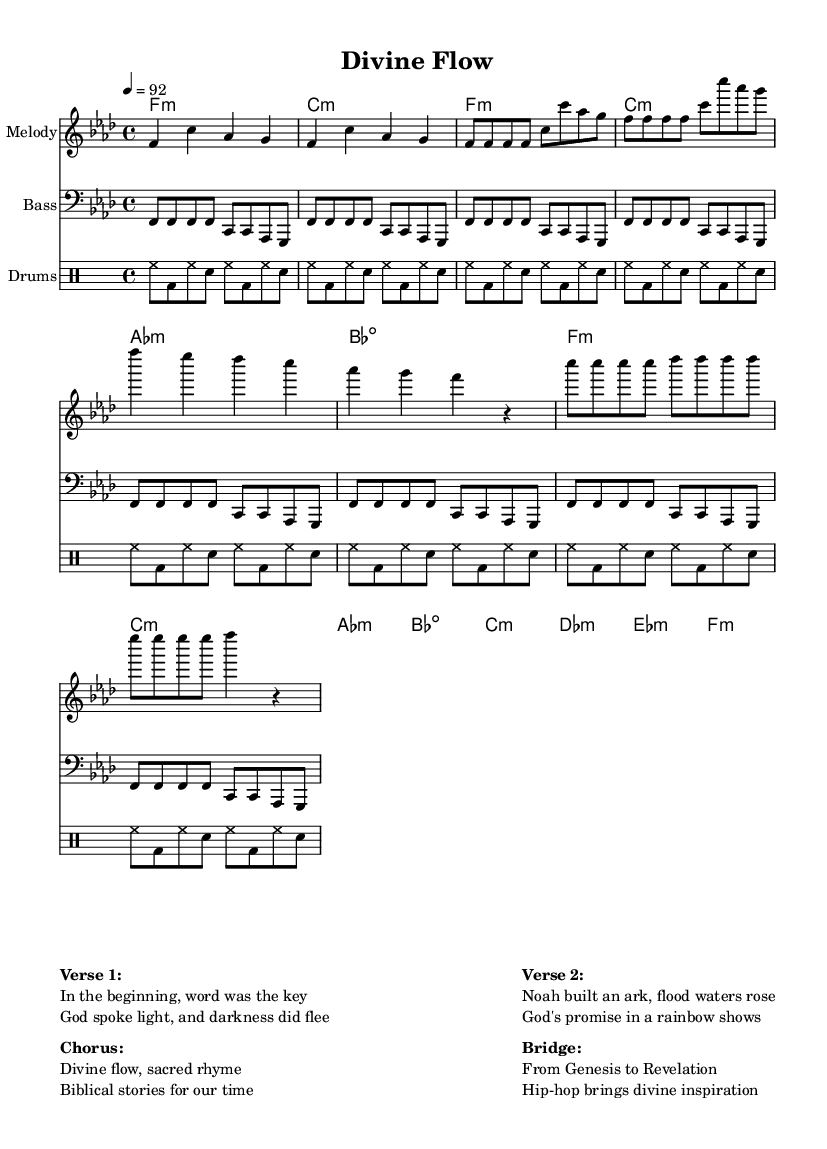What is the key signature of this music? The key signature is F minor, which is indicated at the beginning of the sheet music. This means there are four flats: B-flat, E-flat, A-flat, and D-flat.
Answer: F minor What is the time signature of this piece? The time signature is 4/4, which is indicated at the beginning of the sheet music. This means there are four beats in each measure and the quarter note receives one beat.
Answer: 4/4 What is the tempo marking for this song? The tempo marking is specified as "4 = 92," meaning there are 92 beats per minute with the quarter note. This gives a moderate pace for the rap.
Answer: 92 How many measures are in the verse section? By counting the measures in the melody where the verses are indicated, there are a total of 6 measures in the verse section.
Answer: 6 What is the underlying theme of the lyrics in the bridge? The bridge speaks about "Genesis to Revelation" and suggests that Hip-hop provides "divine inspiration," indicating a connection between religious texts and modern expression through rap.
Answer: Divine inspiration In which section does the line "God's promise in a rainbow shows" appear? This line appears in Verse 2, which reflects on the biblical story of Noah and the flood, tying religious themes to the lyrics.
Answer: Verse 2 